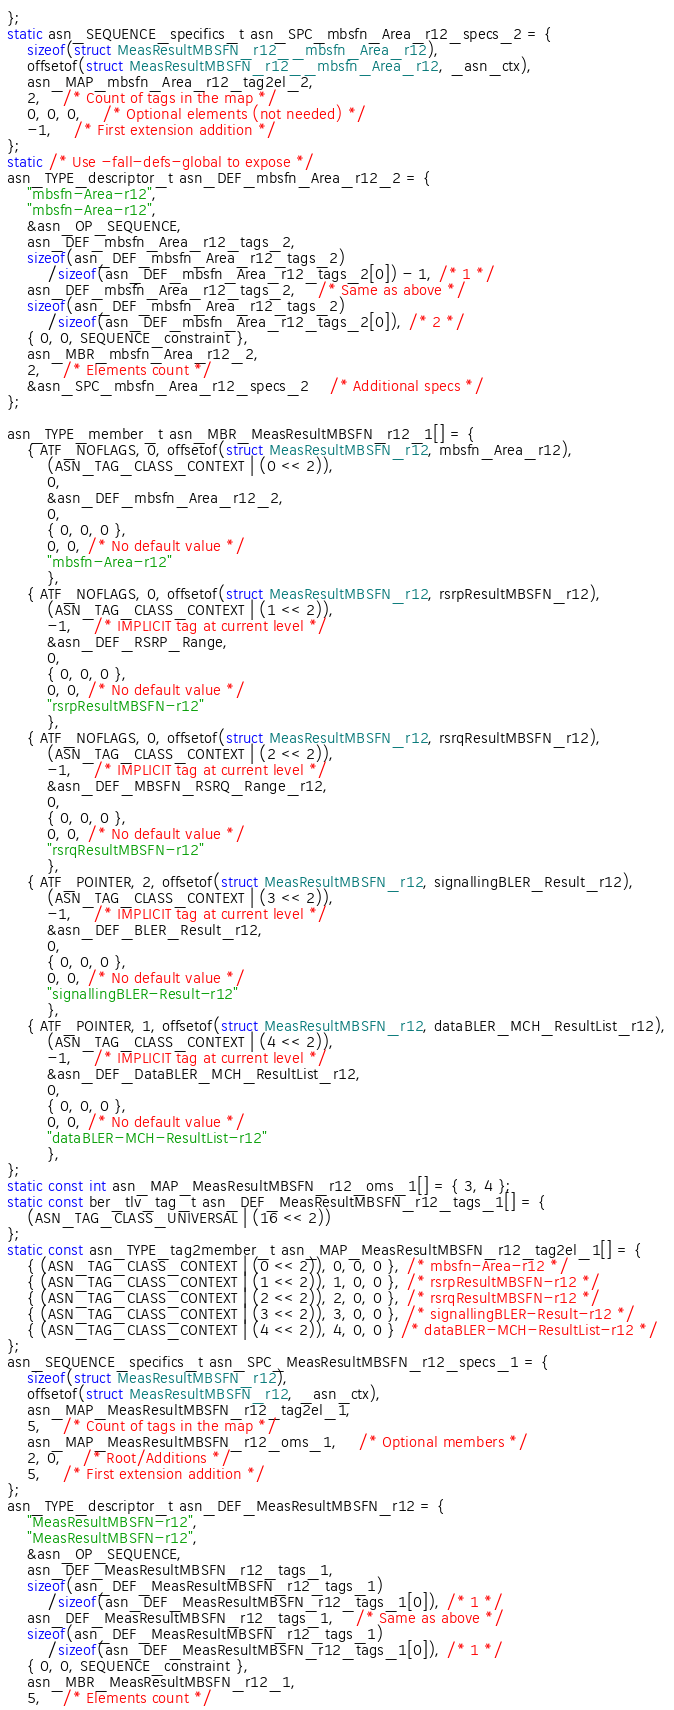<code> <loc_0><loc_0><loc_500><loc_500><_C_>};
static asn_SEQUENCE_specifics_t asn_SPC_mbsfn_Area_r12_specs_2 = {
	sizeof(struct MeasResultMBSFN_r12__mbsfn_Area_r12),
	offsetof(struct MeasResultMBSFN_r12__mbsfn_Area_r12, _asn_ctx),
	asn_MAP_mbsfn_Area_r12_tag2el_2,
	2,	/* Count of tags in the map */
	0, 0, 0,	/* Optional elements (not needed) */
	-1,	/* First extension addition */
};
static /* Use -fall-defs-global to expose */
asn_TYPE_descriptor_t asn_DEF_mbsfn_Area_r12_2 = {
	"mbsfn-Area-r12",
	"mbsfn-Area-r12",
	&asn_OP_SEQUENCE,
	asn_DEF_mbsfn_Area_r12_tags_2,
	sizeof(asn_DEF_mbsfn_Area_r12_tags_2)
		/sizeof(asn_DEF_mbsfn_Area_r12_tags_2[0]) - 1, /* 1 */
	asn_DEF_mbsfn_Area_r12_tags_2,	/* Same as above */
	sizeof(asn_DEF_mbsfn_Area_r12_tags_2)
		/sizeof(asn_DEF_mbsfn_Area_r12_tags_2[0]), /* 2 */
	{ 0, 0, SEQUENCE_constraint },
	asn_MBR_mbsfn_Area_r12_2,
	2,	/* Elements count */
	&asn_SPC_mbsfn_Area_r12_specs_2	/* Additional specs */
};

asn_TYPE_member_t asn_MBR_MeasResultMBSFN_r12_1[] = {
	{ ATF_NOFLAGS, 0, offsetof(struct MeasResultMBSFN_r12, mbsfn_Area_r12),
		(ASN_TAG_CLASS_CONTEXT | (0 << 2)),
		0,
		&asn_DEF_mbsfn_Area_r12_2,
		0,
		{ 0, 0, 0 },
		0, 0, /* No default value */
		"mbsfn-Area-r12"
		},
	{ ATF_NOFLAGS, 0, offsetof(struct MeasResultMBSFN_r12, rsrpResultMBSFN_r12),
		(ASN_TAG_CLASS_CONTEXT | (1 << 2)),
		-1,	/* IMPLICIT tag at current level */
		&asn_DEF_RSRP_Range,
		0,
		{ 0, 0, 0 },
		0, 0, /* No default value */
		"rsrpResultMBSFN-r12"
		},
	{ ATF_NOFLAGS, 0, offsetof(struct MeasResultMBSFN_r12, rsrqResultMBSFN_r12),
		(ASN_TAG_CLASS_CONTEXT | (2 << 2)),
		-1,	/* IMPLICIT tag at current level */
		&asn_DEF_MBSFN_RSRQ_Range_r12,
		0,
		{ 0, 0, 0 },
		0, 0, /* No default value */
		"rsrqResultMBSFN-r12"
		},
	{ ATF_POINTER, 2, offsetof(struct MeasResultMBSFN_r12, signallingBLER_Result_r12),
		(ASN_TAG_CLASS_CONTEXT | (3 << 2)),
		-1,	/* IMPLICIT tag at current level */
		&asn_DEF_BLER_Result_r12,
		0,
		{ 0, 0, 0 },
		0, 0, /* No default value */
		"signallingBLER-Result-r12"
		},
	{ ATF_POINTER, 1, offsetof(struct MeasResultMBSFN_r12, dataBLER_MCH_ResultList_r12),
		(ASN_TAG_CLASS_CONTEXT | (4 << 2)),
		-1,	/* IMPLICIT tag at current level */
		&asn_DEF_DataBLER_MCH_ResultList_r12,
		0,
		{ 0, 0, 0 },
		0, 0, /* No default value */
		"dataBLER-MCH-ResultList-r12"
		},
};
static const int asn_MAP_MeasResultMBSFN_r12_oms_1[] = { 3, 4 };
static const ber_tlv_tag_t asn_DEF_MeasResultMBSFN_r12_tags_1[] = {
	(ASN_TAG_CLASS_UNIVERSAL | (16 << 2))
};
static const asn_TYPE_tag2member_t asn_MAP_MeasResultMBSFN_r12_tag2el_1[] = {
    { (ASN_TAG_CLASS_CONTEXT | (0 << 2)), 0, 0, 0 }, /* mbsfn-Area-r12 */
    { (ASN_TAG_CLASS_CONTEXT | (1 << 2)), 1, 0, 0 }, /* rsrpResultMBSFN-r12 */
    { (ASN_TAG_CLASS_CONTEXT | (2 << 2)), 2, 0, 0 }, /* rsrqResultMBSFN-r12 */
    { (ASN_TAG_CLASS_CONTEXT | (3 << 2)), 3, 0, 0 }, /* signallingBLER-Result-r12 */
    { (ASN_TAG_CLASS_CONTEXT | (4 << 2)), 4, 0, 0 } /* dataBLER-MCH-ResultList-r12 */
};
asn_SEQUENCE_specifics_t asn_SPC_MeasResultMBSFN_r12_specs_1 = {
	sizeof(struct MeasResultMBSFN_r12),
	offsetof(struct MeasResultMBSFN_r12, _asn_ctx),
	asn_MAP_MeasResultMBSFN_r12_tag2el_1,
	5,	/* Count of tags in the map */
	asn_MAP_MeasResultMBSFN_r12_oms_1,	/* Optional members */
	2, 0,	/* Root/Additions */
	5,	/* First extension addition */
};
asn_TYPE_descriptor_t asn_DEF_MeasResultMBSFN_r12 = {
	"MeasResultMBSFN-r12",
	"MeasResultMBSFN-r12",
	&asn_OP_SEQUENCE,
	asn_DEF_MeasResultMBSFN_r12_tags_1,
	sizeof(asn_DEF_MeasResultMBSFN_r12_tags_1)
		/sizeof(asn_DEF_MeasResultMBSFN_r12_tags_1[0]), /* 1 */
	asn_DEF_MeasResultMBSFN_r12_tags_1,	/* Same as above */
	sizeof(asn_DEF_MeasResultMBSFN_r12_tags_1)
		/sizeof(asn_DEF_MeasResultMBSFN_r12_tags_1[0]), /* 1 */
	{ 0, 0, SEQUENCE_constraint },
	asn_MBR_MeasResultMBSFN_r12_1,
	5,	/* Elements count */</code> 